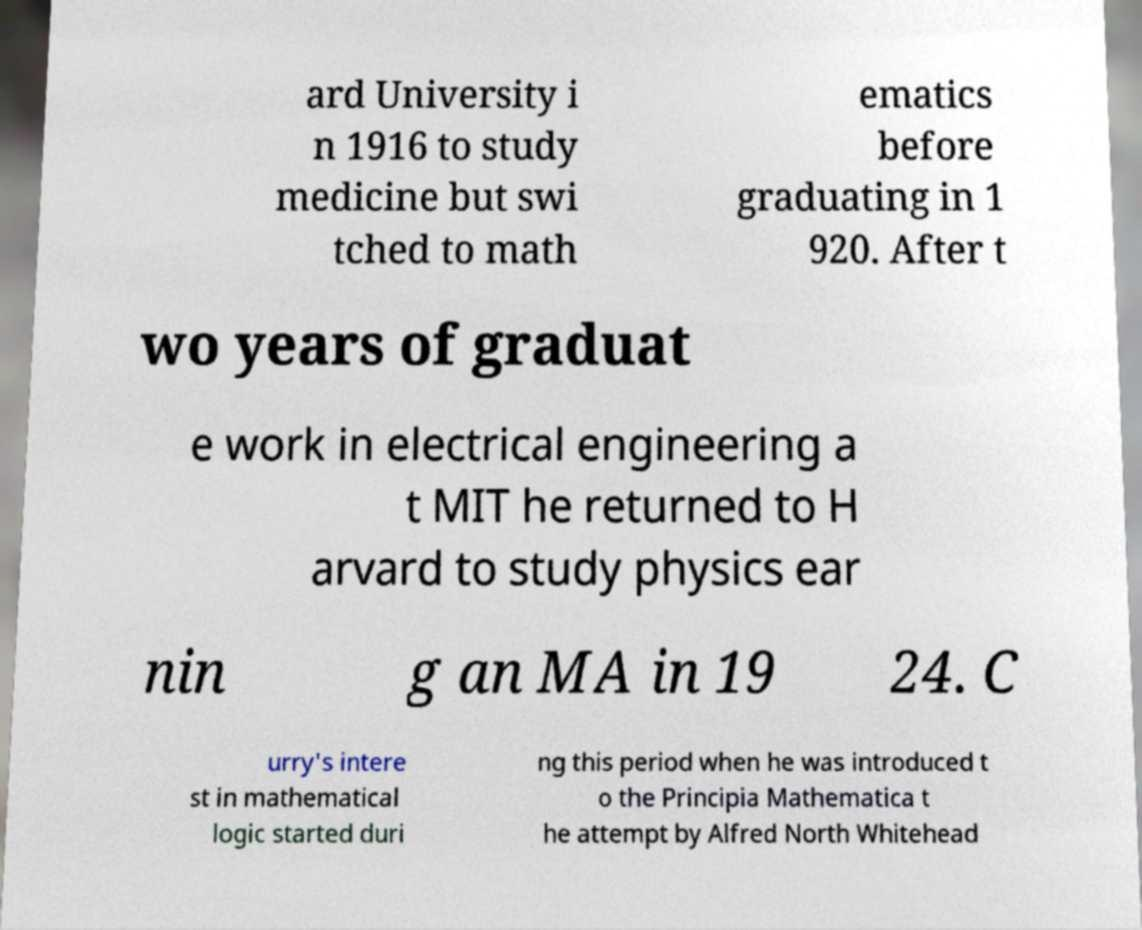I need the written content from this picture converted into text. Can you do that? ard University i n 1916 to study medicine but swi tched to math ematics before graduating in 1 920. After t wo years of graduat e work in electrical engineering a t MIT he returned to H arvard to study physics ear nin g an MA in 19 24. C urry's intere st in mathematical logic started duri ng this period when he was introduced t o the Principia Mathematica t he attempt by Alfred North Whitehead 